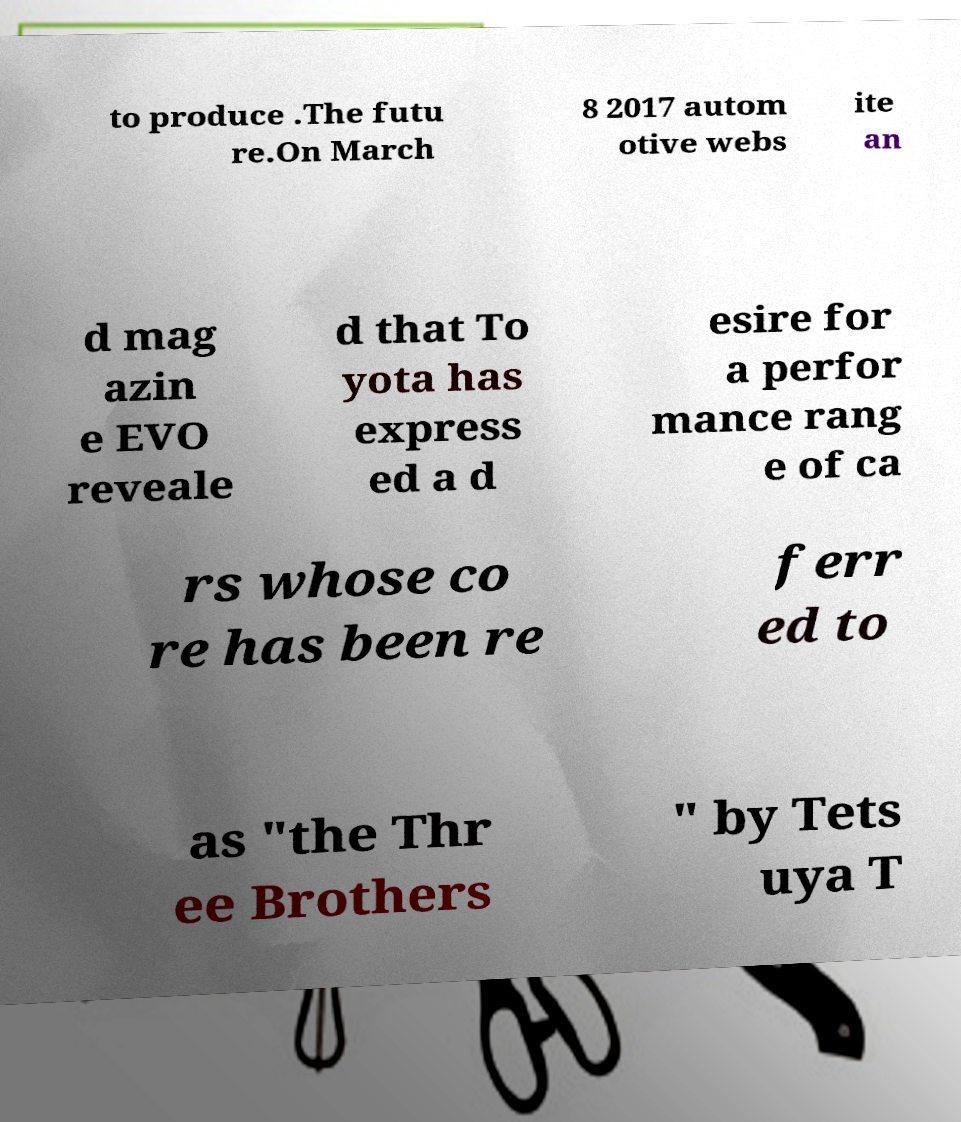What messages or text are displayed in this image? I need them in a readable, typed format. to produce .The futu re.On March 8 2017 autom otive webs ite an d mag azin e EVO reveale d that To yota has express ed a d esire for a perfor mance rang e of ca rs whose co re has been re ferr ed to as "the Thr ee Brothers " by Tets uya T 